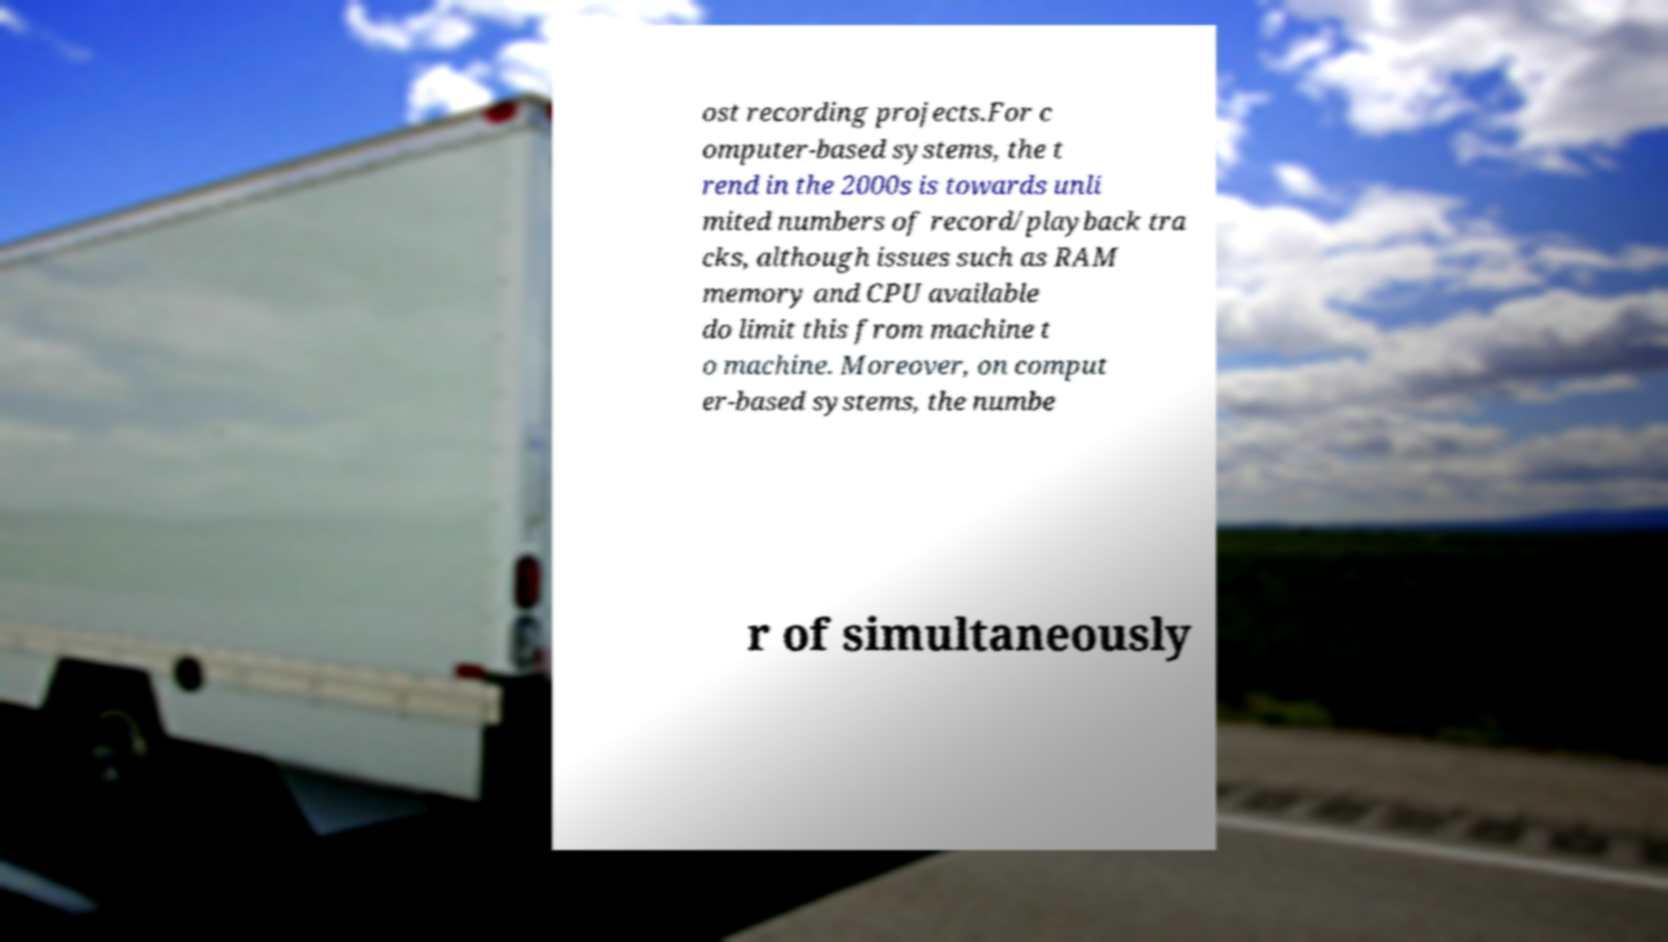What messages or text are displayed in this image? I need them in a readable, typed format. ost recording projects.For c omputer-based systems, the t rend in the 2000s is towards unli mited numbers of record/playback tra cks, although issues such as RAM memory and CPU available do limit this from machine t o machine. Moreover, on comput er-based systems, the numbe r of simultaneously 